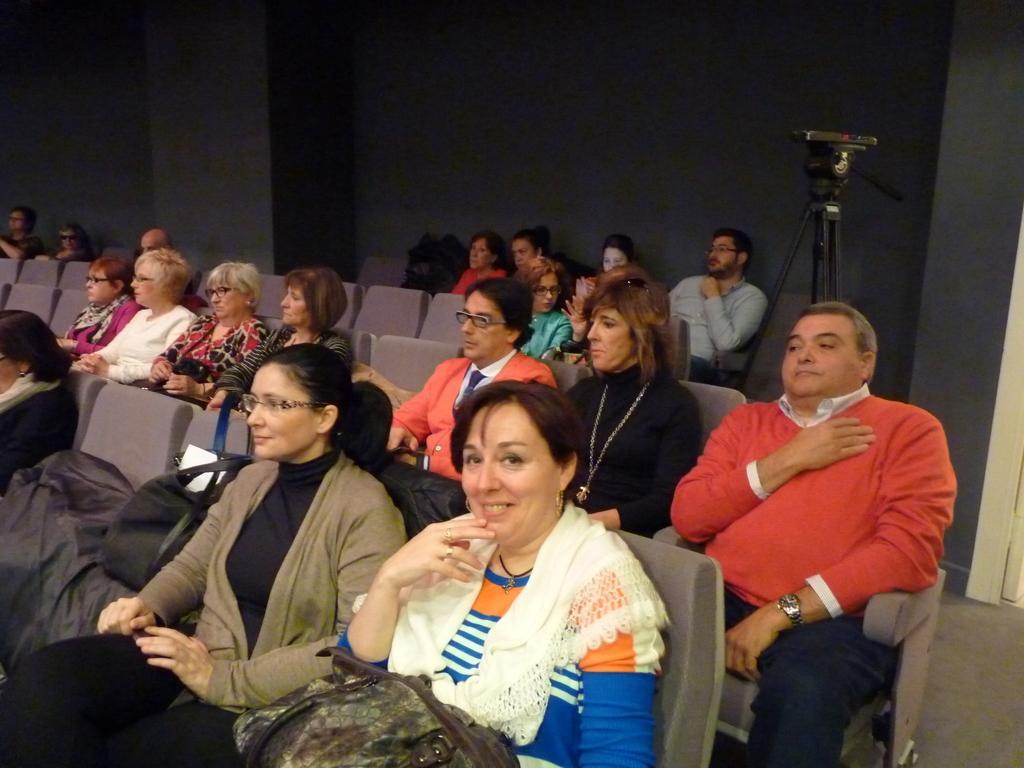Describe this image in one or two sentences. Here people are sitting on the chairs, this is camera, this is wall. 